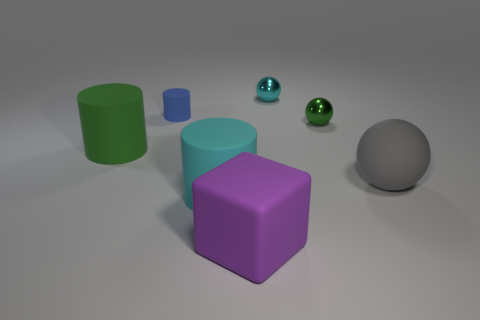Subtract all blue rubber cylinders. How many cylinders are left? 2 Add 1 purple cubes. How many objects exist? 8 Subtract all red spheres. How many blue blocks are left? 0 Subtract all gray spheres. How many spheres are left? 2 Subtract 1 spheres. How many spheres are left? 2 Subtract all small cylinders. Subtract all large gray matte objects. How many objects are left? 5 Add 6 purple things. How many purple things are left? 7 Add 4 tiny brown metal blocks. How many tiny brown metal blocks exist? 4 Subtract 1 cyan cylinders. How many objects are left? 6 Subtract all spheres. How many objects are left? 4 